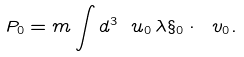Convert formula to latex. <formula><loc_0><loc_0><loc_500><loc_500>P _ { 0 } = m \int d ^ { 3 } \ u _ { 0 } \, \lambda \S _ { 0 } \cdot \ v _ { 0 } .</formula> 